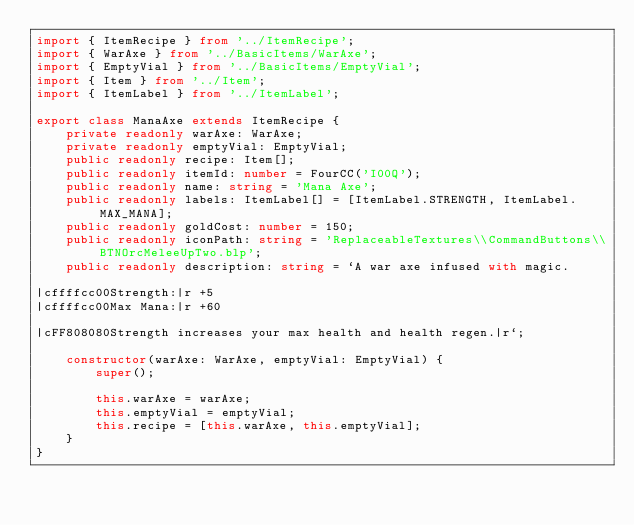<code> <loc_0><loc_0><loc_500><loc_500><_TypeScript_>import { ItemRecipe } from '../ItemRecipe';
import { WarAxe } from '../BasicItems/WarAxe';
import { EmptyVial } from '../BasicItems/EmptyVial';
import { Item } from '../Item';
import { ItemLabel } from '../ItemLabel';

export class ManaAxe extends ItemRecipe {
    private readonly warAxe: WarAxe;
    private readonly emptyVial: EmptyVial;
    public readonly recipe: Item[];
    public readonly itemId: number = FourCC('I00Q');
    public readonly name: string = 'Mana Axe';
    public readonly labels: ItemLabel[] = [ItemLabel.STRENGTH, ItemLabel.MAX_MANA];
    public readonly goldCost: number = 150;
    public readonly iconPath: string = 'ReplaceableTextures\\CommandButtons\\BTNOrcMeleeUpTwo.blp';
    public readonly description: string = `A war axe infused with magic.

|cffffcc00Strength:|r +5
|cffffcc00Max Mana:|r +60

|cFF808080Strength increases your max health and health regen.|r`;

    constructor(warAxe: WarAxe, emptyVial: EmptyVial) {
        super();

        this.warAxe = warAxe;
        this.emptyVial = emptyVial;
        this.recipe = [this.warAxe, this.emptyVial];
    }
}
</code> 